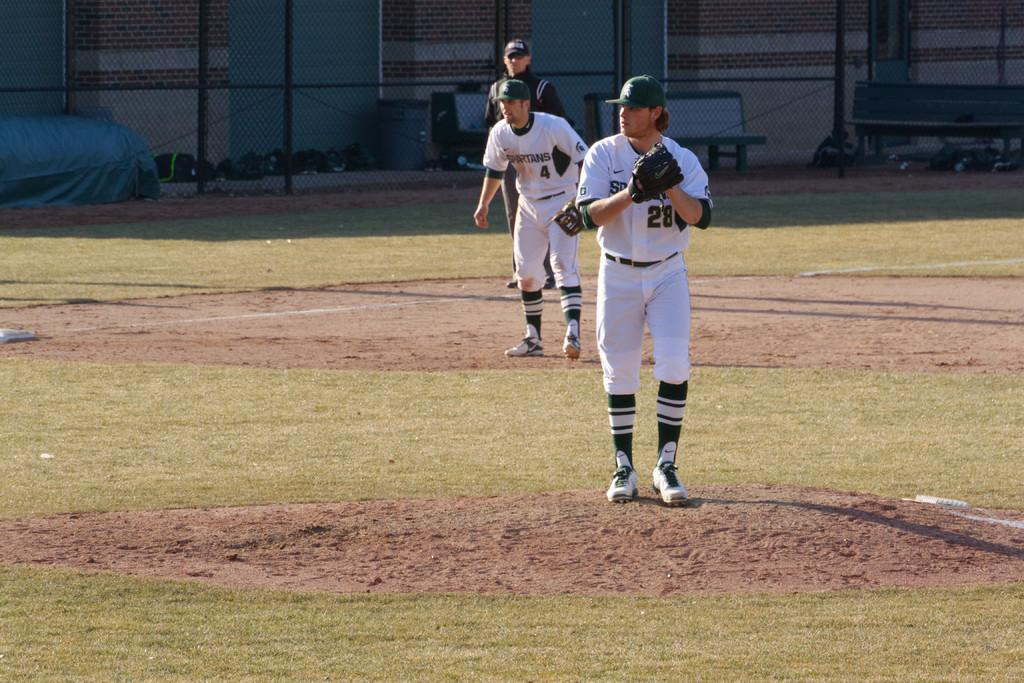<image>
Create a compact narrative representing the image presented. Player 4 and 28 from the Spartans are on the field. 